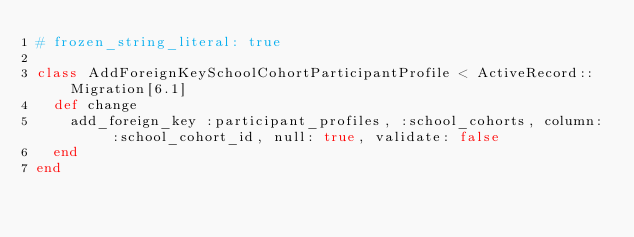Convert code to text. <code><loc_0><loc_0><loc_500><loc_500><_Ruby_># frozen_string_literal: true

class AddForeignKeySchoolCohortParticipantProfile < ActiveRecord::Migration[6.1]
  def change
    add_foreign_key :participant_profiles, :school_cohorts, column: :school_cohort_id, null: true, validate: false
  end
end
</code> 